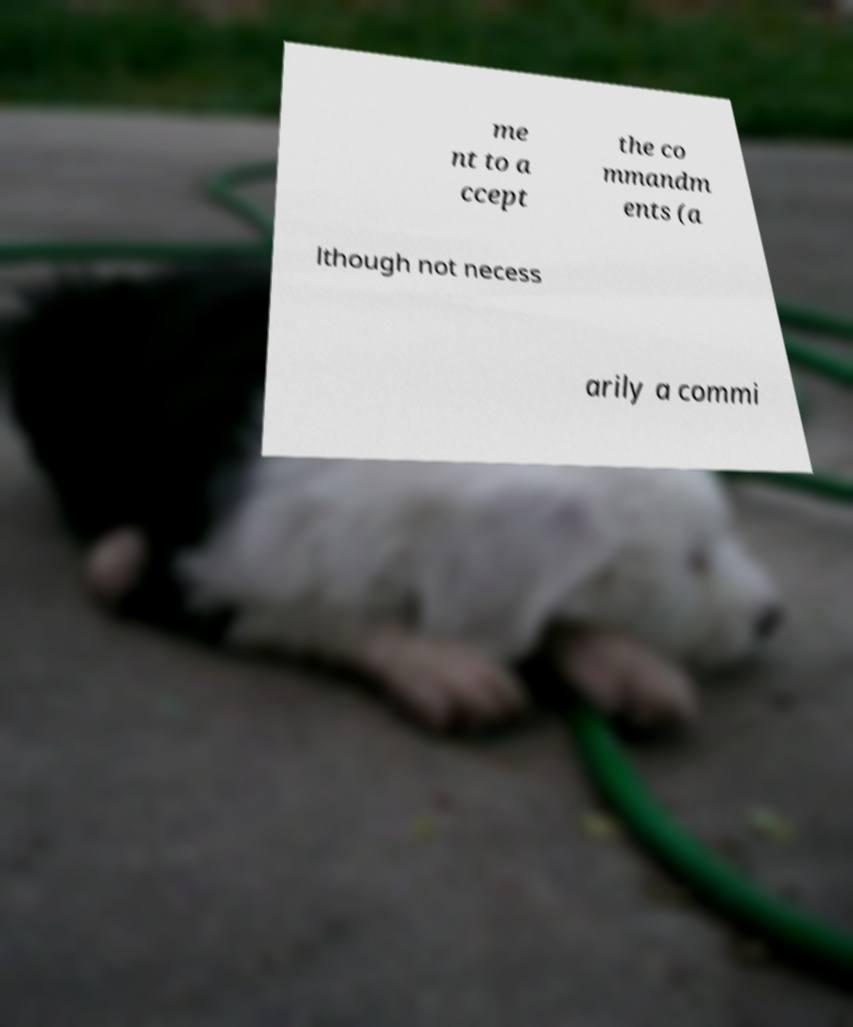For documentation purposes, I need the text within this image transcribed. Could you provide that? me nt to a ccept the co mmandm ents (a lthough not necess arily a commi 